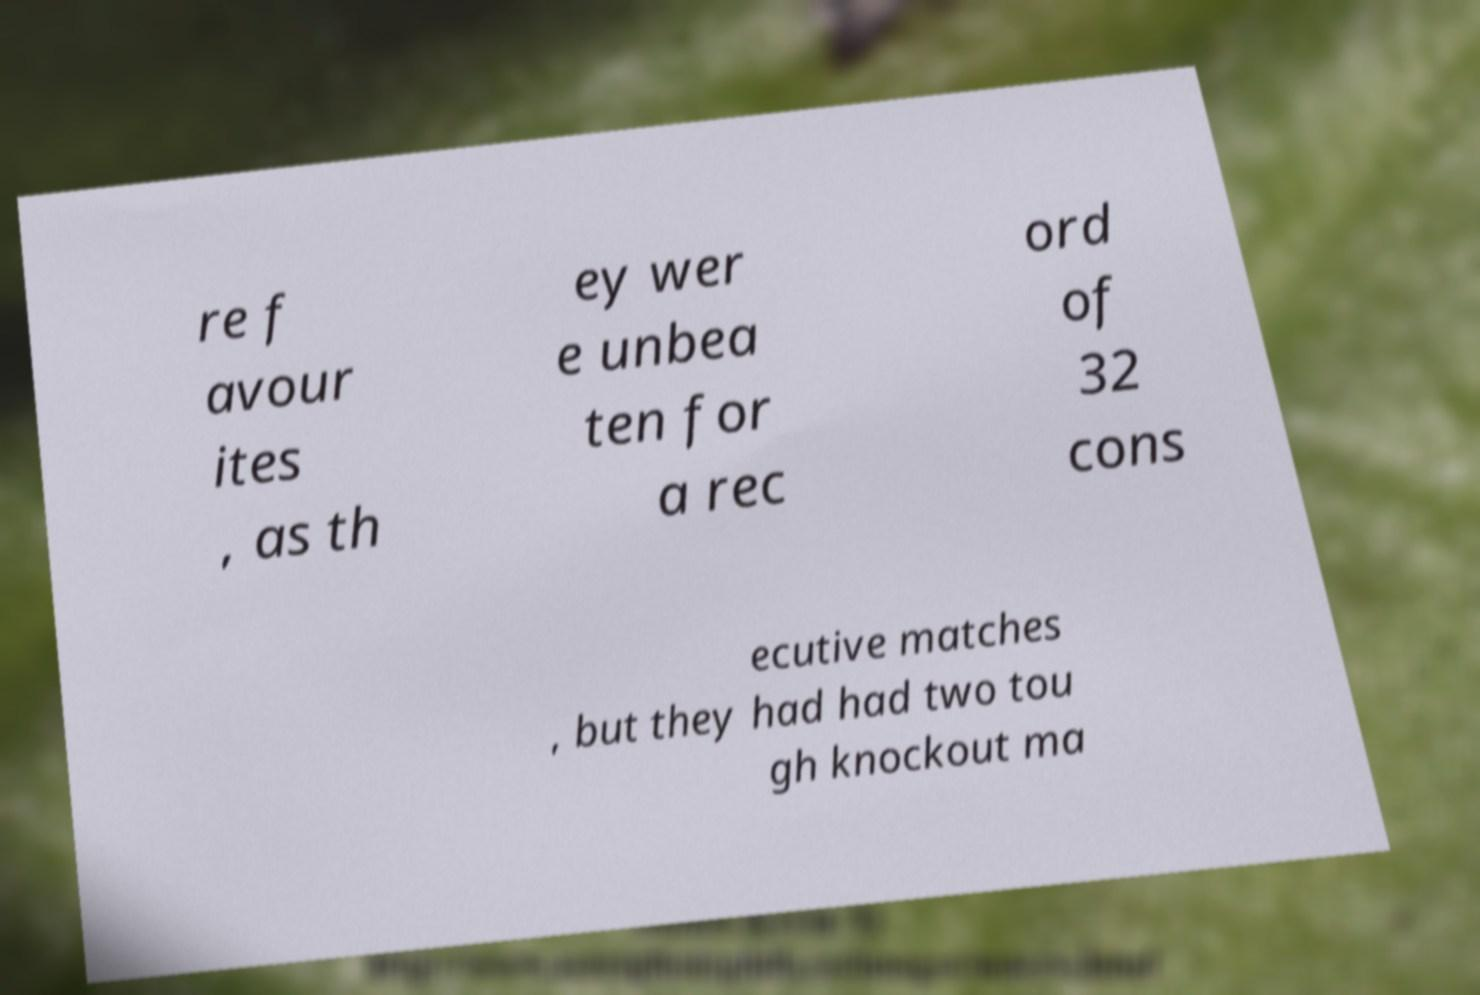What messages or text are displayed in this image? I need them in a readable, typed format. re f avour ites , as th ey wer e unbea ten for a rec ord of 32 cons ecutive matches , but they had had two tou gh knockout ma 